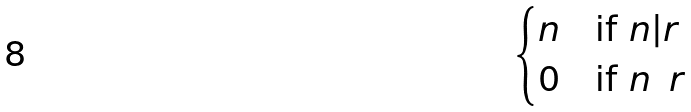Convert formula to latex. <formula><loc_0><loc_0><loc_500><loc_500>\begin{cases} n & \text {if $n|r$} \\ 0 & \text {if $n \nmid r$} \end{cases}</formula> 